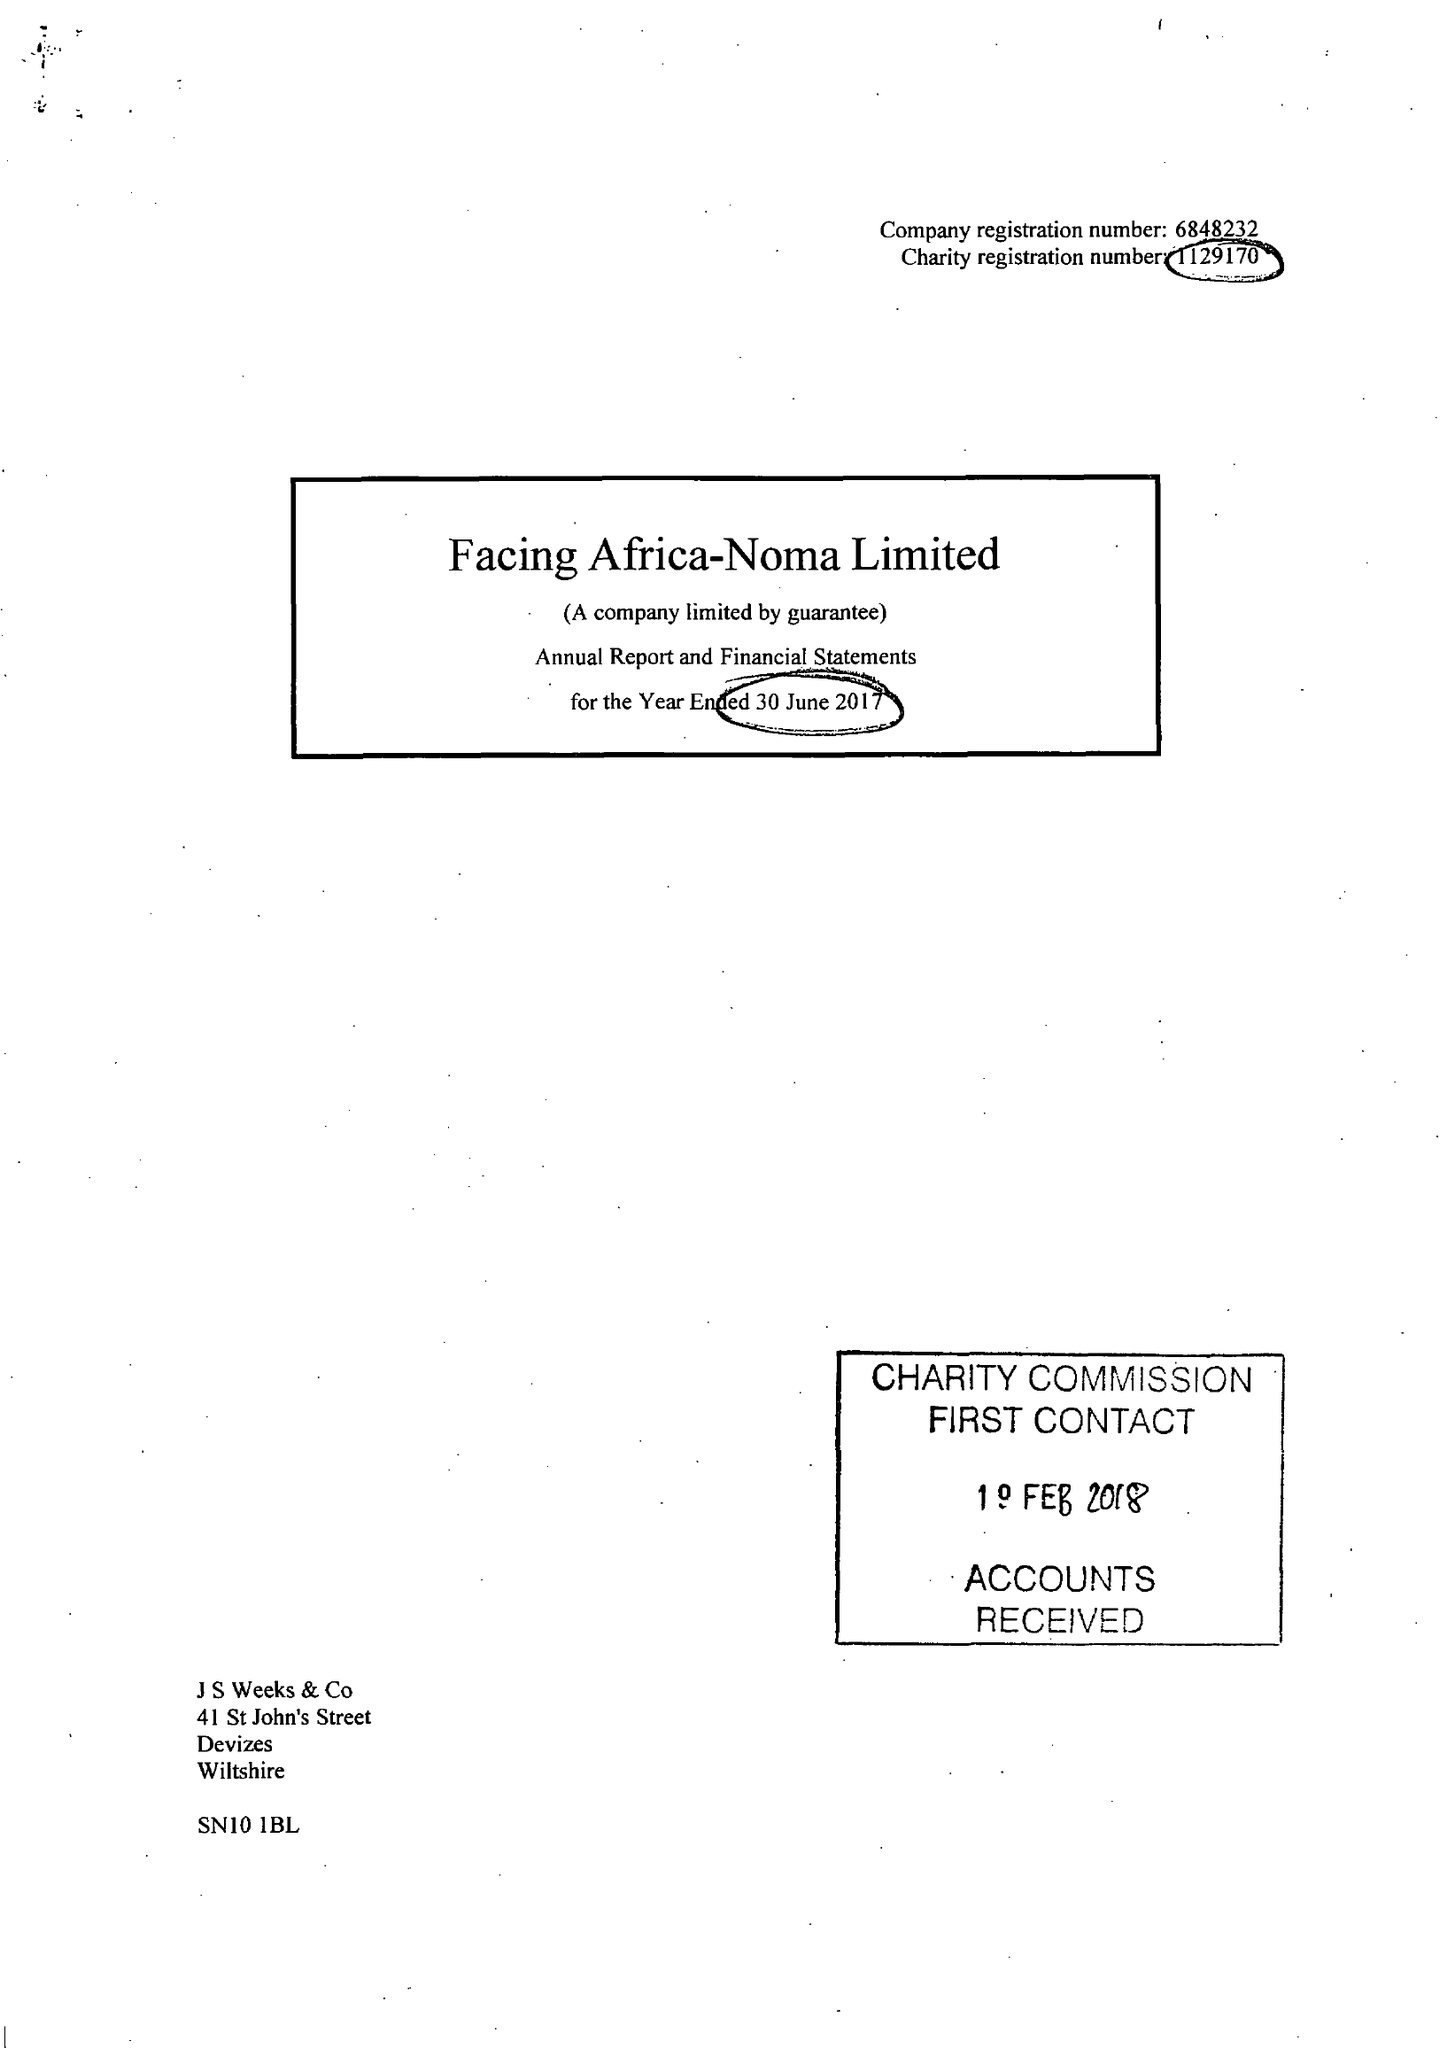What is the value for the address__street_line?
Answer the question using a single word or phrase. WINE STREET 